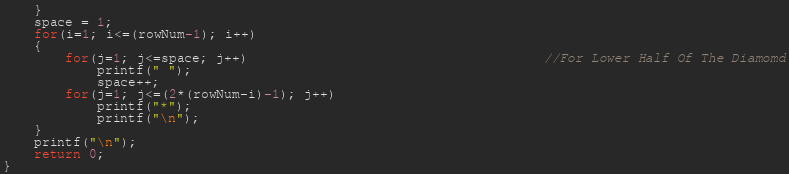Convert code to text. <code><loc_0><loc_0><loc_500><loc_500><_C_>    }
    space = 1;
    for(i=1; i<=(rowNum-1); i++)
    {
        for(j=1; j<=space; j++)                                      //For Lower Half Of The Diamomd
            printf(" ");
            space++;
        for(j=1; j<=(2*(rowNum-i)-1); j++)
            printf("*");
            printf("\n");
    }
    printf("\n");
    return 0;
}
</code> 